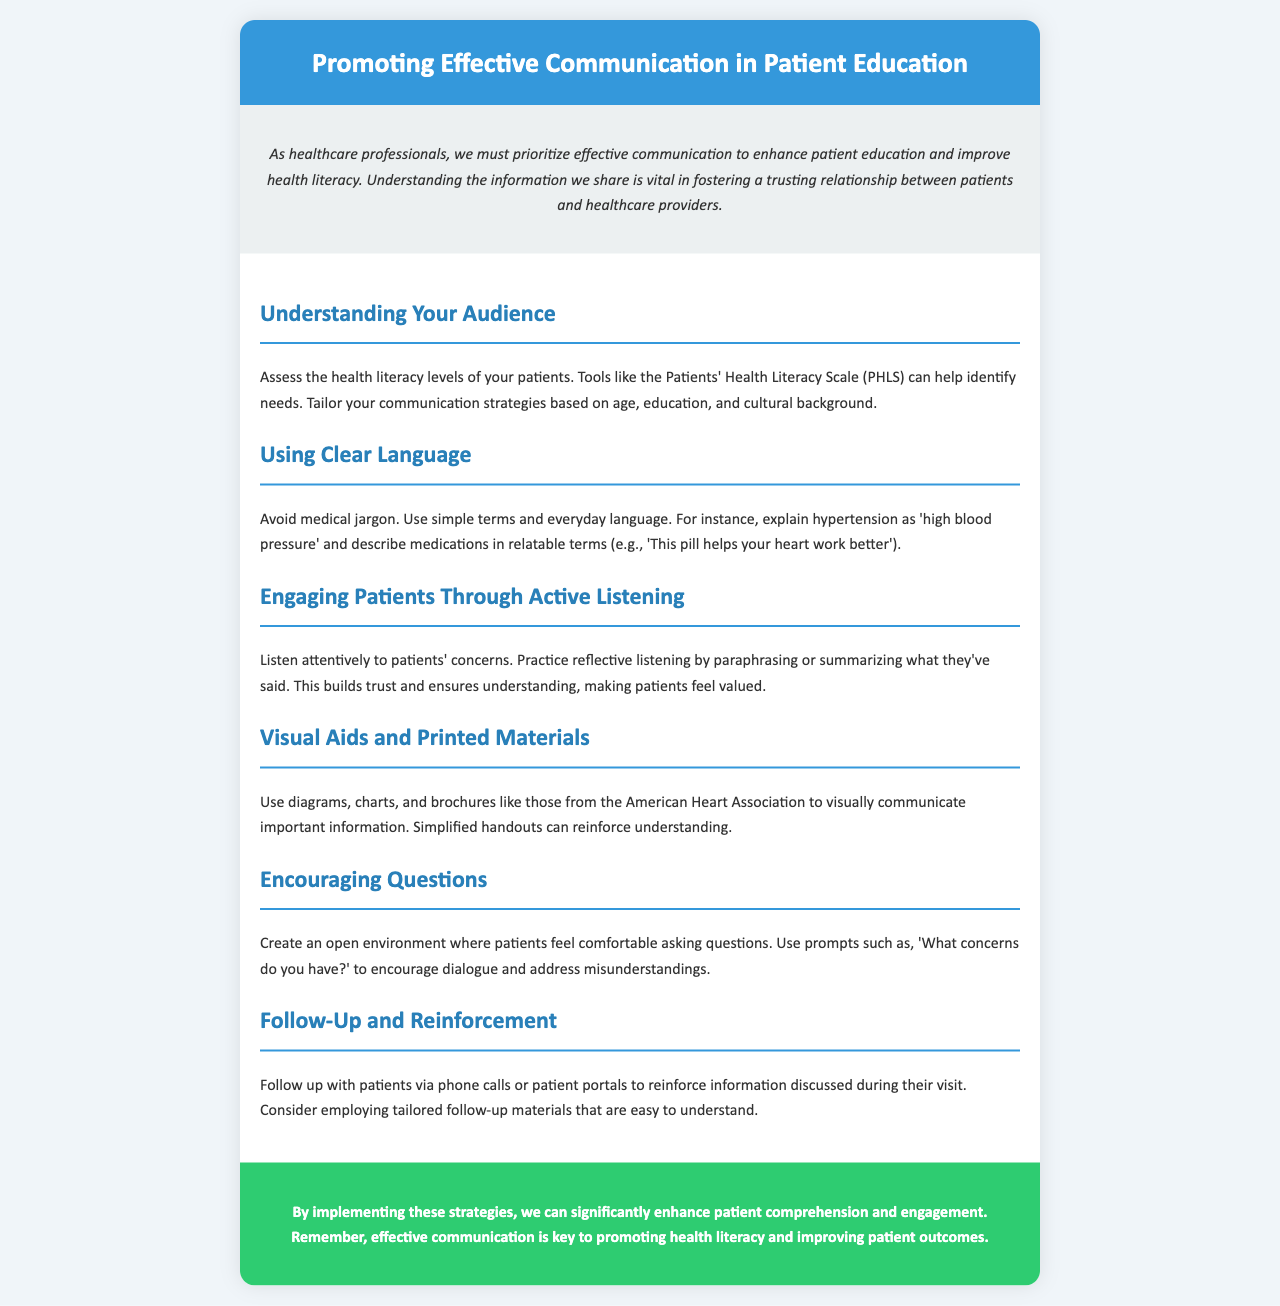What is the title of the brochure? The title is prominently displayed at the top of the document, indicating the main focus of the content.
Answer: Promoting Effective Communication in Patient Education What is one tool mentioned for assessing health literacy? The document lists a specific tool used for evaluating patients' health literacy levels to tailor communication strategies accordingly.
Answer: Patients' Health Literacy Scale (PHLS) What should healthcare professionals avoid when communicating with patients? The content specifies certain types of language that should be avoided to promote better understanding among patients.
Answer: Medical jargon What is one method to engage patients according to the brochure? The document highlights a specific approach that helps healthcare professionals to better connect with their patients during communication.
Answer: Active listening What type of aids can enhance understanding in patient education? The brochure suggests tools that can visually support the communication process, making complex information easier to grasp.
Answer: Visual aids What is a suggested follow-up method for reinforcing information? The document proposes a specific action to ensure that patients continue to receive support and understanding after their visits.
Answer: Phone calls What is an encouraged action to create an open environment? The content promotes a strategy healthcare professionals can use to facilitate dialogue and questions from patients.
Answer: Encourage questions What color scheme is predominantly used in the brochure? The document describes the general color palette that creates a welcoming and professional appearance throughout the brochure.
Answer: Blue and green 